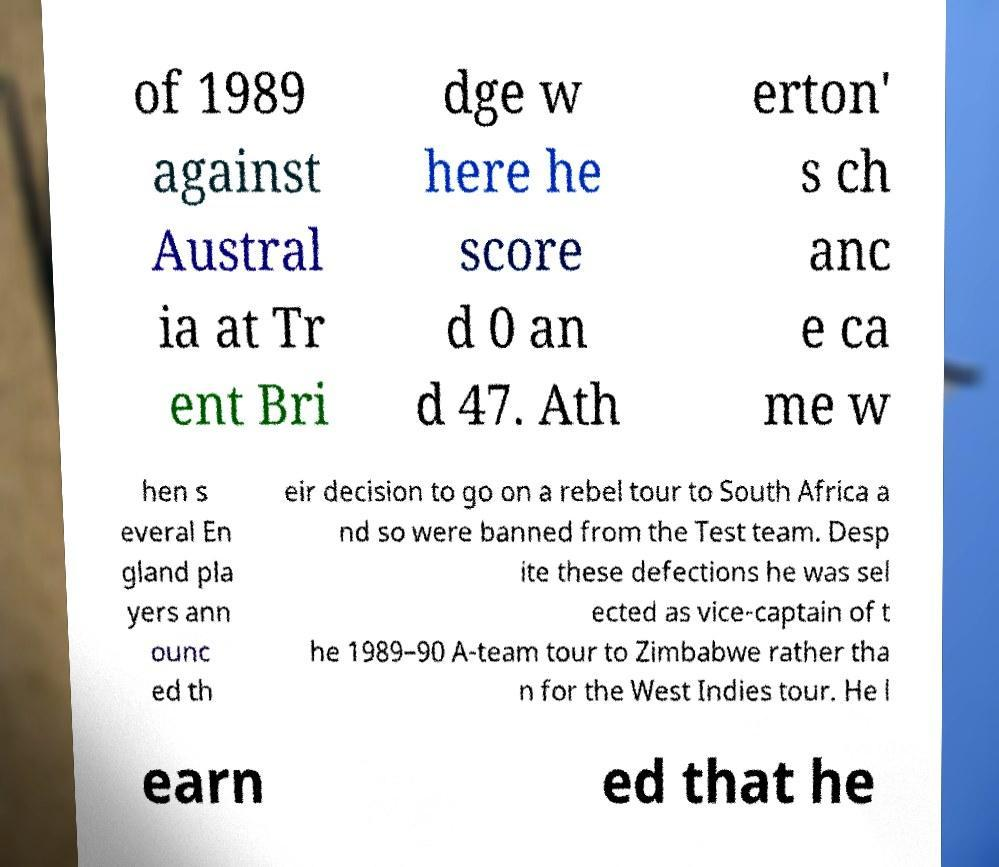Please read and relay the text visible in this image. What does it say? of 1989 against Austral ia at Tr ent Bri dge w here he score d 0 an d 47. Ath erton' s ch anc e ca me w hen s everal En gland pla yers ann ounc ed th eir decision to go on a rebel tour to South Africa a nd so were banned from the Test team. Desp ite these defections he was sel ected as vice-captain of t he 1989–90 A-team tour to Zimbabwe rather tha n for the West Indies tour. He l earn ed that he 